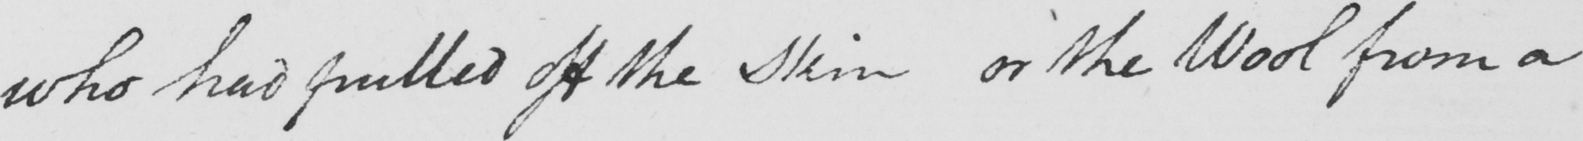What does this handwritten line say? who had pulled off the Skin or the Wool from a 